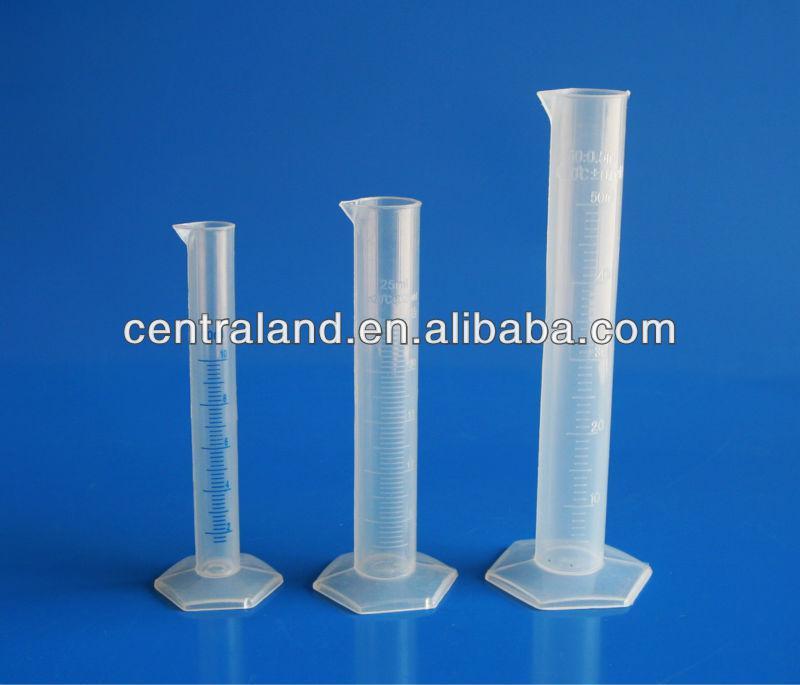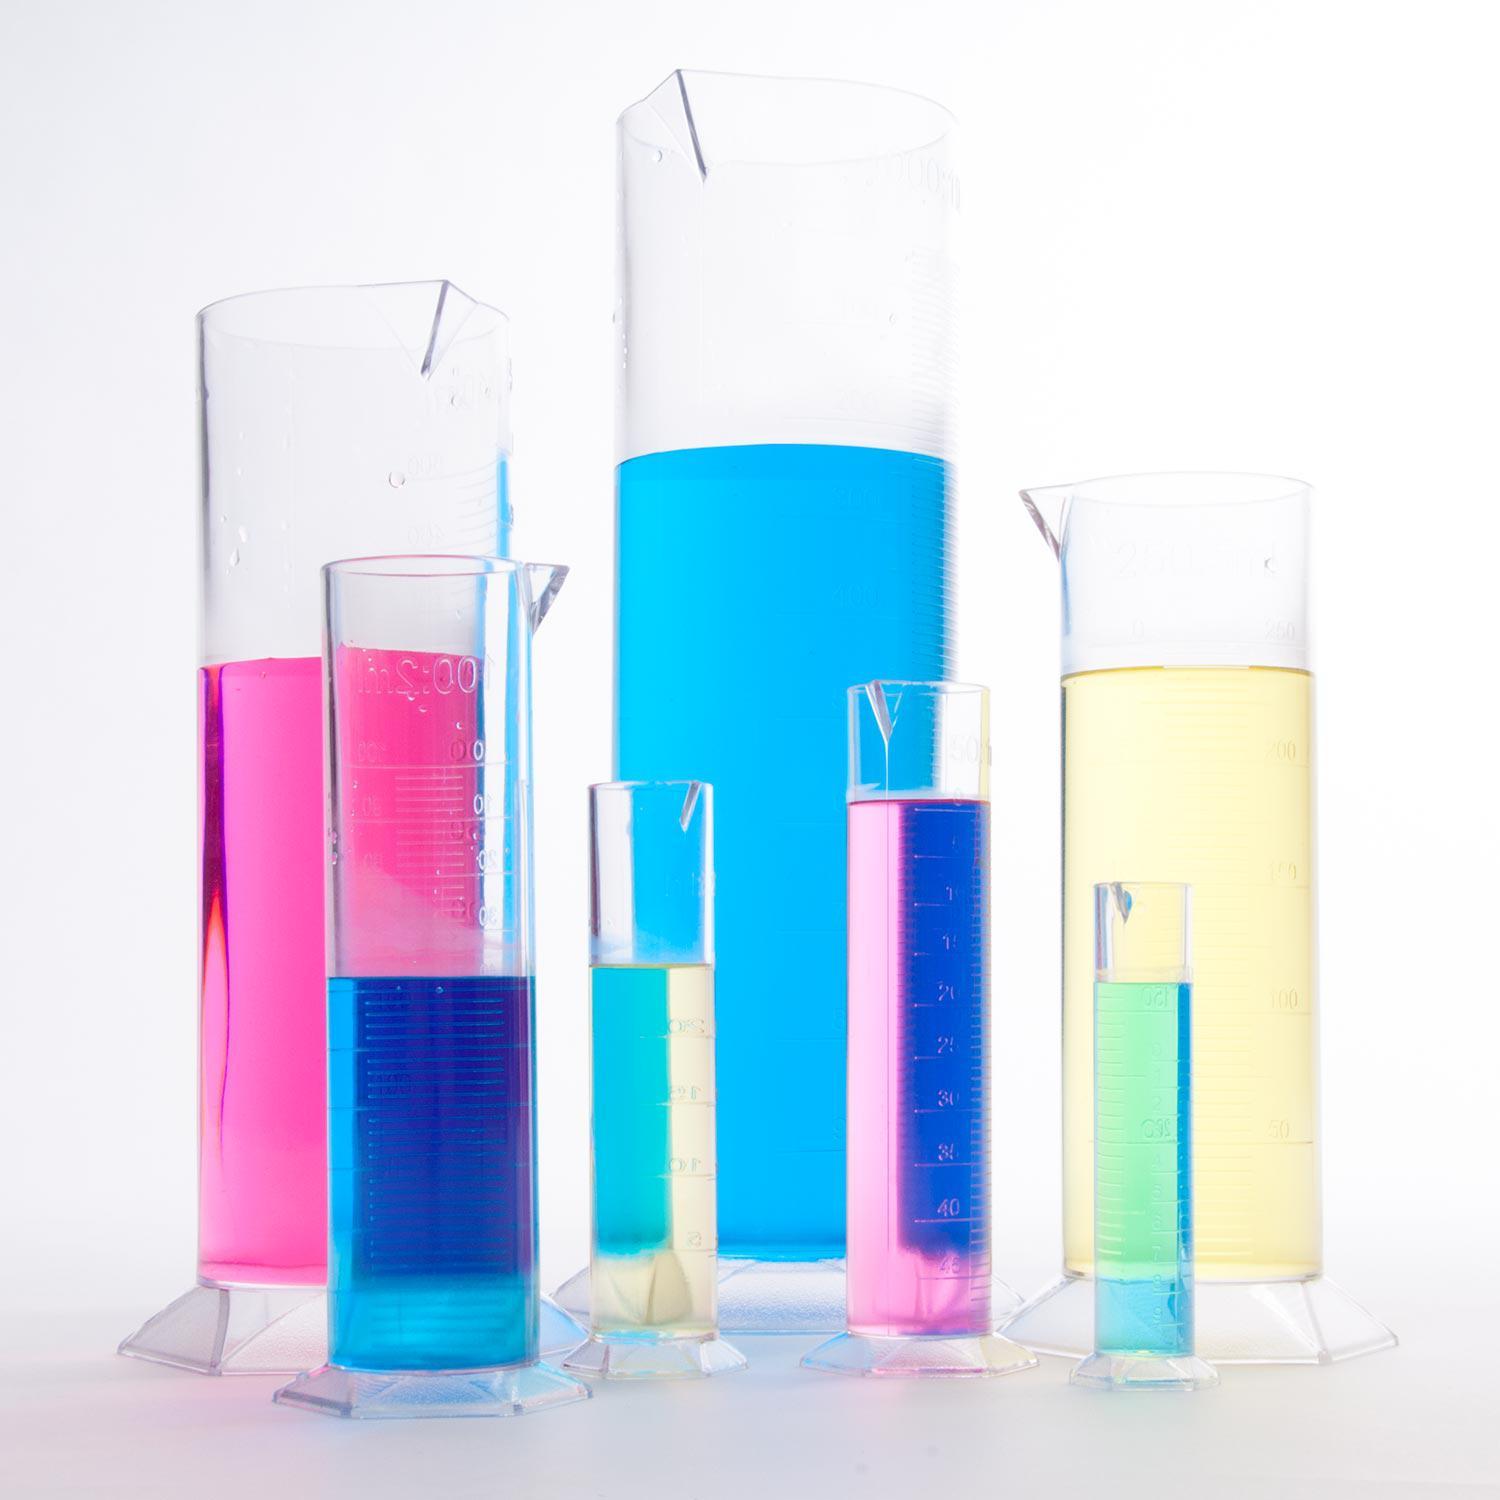The first image is the image on the left, the second image is the image on the right. Examine the images to the left and right. Is the description "Each image includes at least one slender test tube-shaped cylinder that stands on a flat hexagon-shaped base." accurate? Answer yes or no. Yes. The first image is the image on the left, the second image is the image on the right. For the images displayed, is the sentence "There is one cylinder and three beakers." factually correct? Answer yes or no. No. 